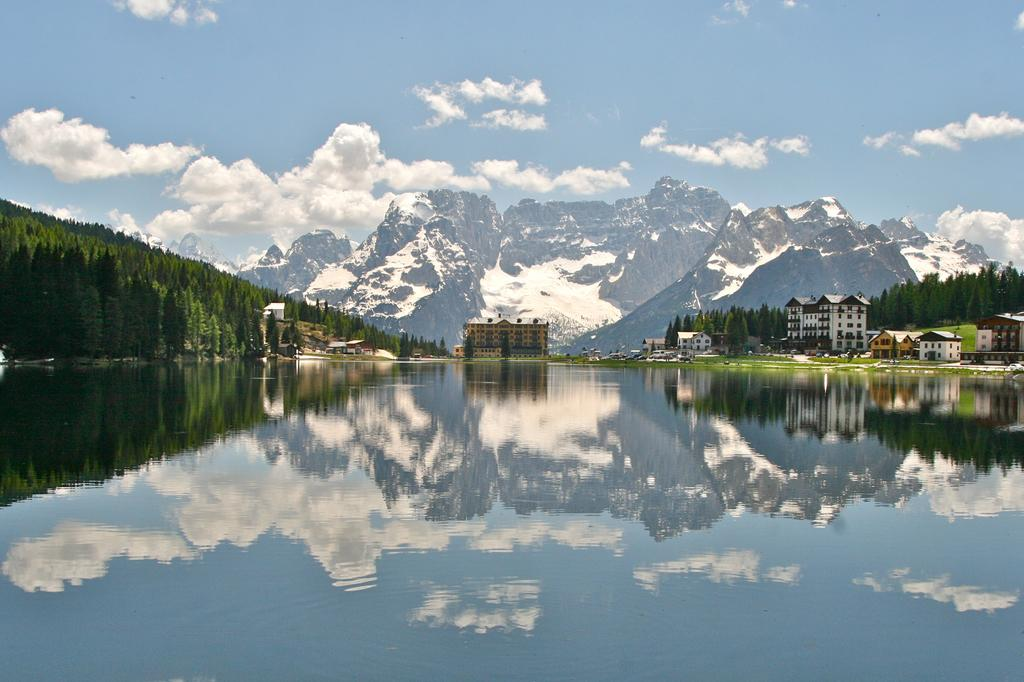What type of natural features can be seen in the image? There are trees and mountains in the image. What type of man-made structures can be seen in the image? There are buildings and houses in the image. What is visible in the sky in the image? The sky is visible in the image, and there are clouds in it. What body of water is present in the image? There is a river at the bottom of the image. How many cans of paint are used to create the light in the image? There is no light or paint present in the image; it features natural and man-made structures, a river, and a sky with clouds. What type of bears can be seen interacting with the houses in the image? There are no bears present in the image; it features houses, buildings, trees, mountains, a river, and a sky with clouds. 